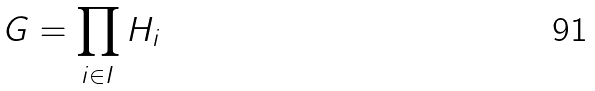Convert formula to latex. <formula><loc_0><loc_0><loc_500><loc_500>G = \prod _ { i \in I } H _ { i }</formula> 